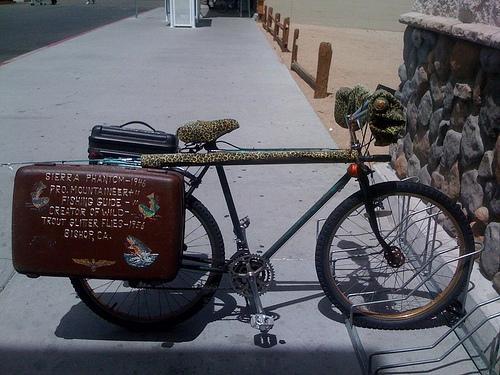What design is the bike seat? Please explain your reasoning. leopard print. Leopard fur is solid golden with small black spots. 